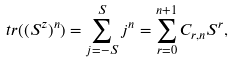Convert formula to latex. <formula><loc_0><loc_0><loc_500><loc_500>t r ( ( S ^ { z } ) ^ { n } ) = \sum _ { j = - S } ^ { S } j ^ { n } = \sum _ { r = 0 } ^ { n + 1 } C _ { r , n } S ^ { r } ,</formula> 